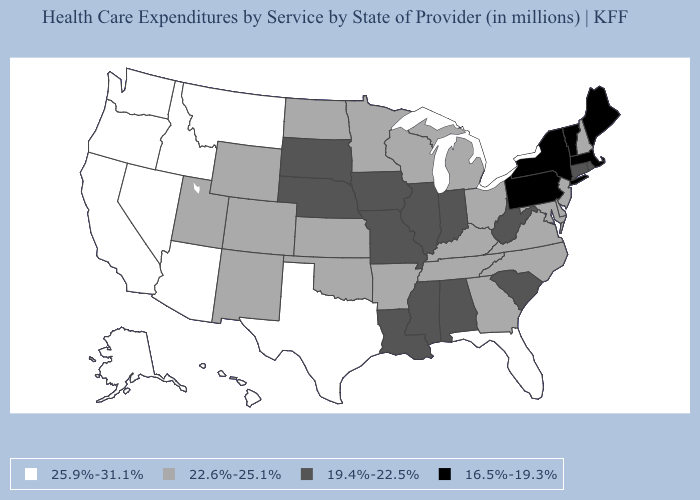Name the states that have a value in the range 22.6%-25.1%?
Keep it brief. Arkansas, Colorado, Delaware, Georgia, Kansas, Kentucky, Maryland, Michigan, Minnesota, New Hampshire, New Jersey, New Mexico, North Carolina, North Dakota, Ohio, Oklahoma, Tennessee, Utah, Virginia, Wisconsin, Wyoming. Does Massachusetts have the lowest value in the Northeast?
Give a very brief answer. Yes. What is the value of Wisconsin?
Write a very short answer. 22.6%-25.1%. Name the states that have a value in the range 22.6%-25.1%?
Write a very short answer. Arkansas, Colorado, Delaware, Georgia, Kansas, Kentucky, Maryland, Michigan, Minnesota, New Hampshire, New Jersey, New Mexico, North Carolina, North Dakota, Ohio, Oklahoma, Tennessee, Utah, Virginia, Wisconsin, Wyoming. What is the value of Oregon?
Write a very short answer. 25.9%-31.1%. What is the value of Oregon?
Short answer required. 25.9%-31.1%. What is the lowest value in states that border Mississippi?
Write a very short answer. 19.4%-22.5%. Name the states that have a value in the range 25.9%-31.1%?
Be succinct. Alaska, Arizona, California, Florida, Hawaii, Idaho, Montana, Nevada, Oregon, Texas, Washington. What is the value of Tennessee?
Quick response, please. 22.6%-25.1%. Name the states that have a value in the range 25.9%-31.1%?
Keep it brief. Alaska, Arizona, California, Florida, Hawaii, Idaho, Montana, Nevada, Oregon, Texas, Washington. What is the lowest value in the MidWest?
Be succinct. 19.4%-22.5%. Does South Dakota have a lower value than New Hampshire?
Give a very brief answer. Yes. Name the states that have a value in the range 22.6%-25.1%?
Write a very short answer. Arkansas, Colorado, Delaware, Georgia, Kansas, Kentucky, Maryland, Michigan, Minnesota, New Hampshire, New Jersey, New Mexico, North Carolina, North Dakota, Ohio, Oklahoma, Tennessee, Utah, Virginia, Wisconsin, Wyoming. What is the highest value in states that border South Carolina?
Keep it brief. 22.6%-25.1%. Name the states that have a value in the range 16.5%-19.3%?
Keep it brief. Maine, Massachusetts, New York, Pennsylvania, Vermont. 